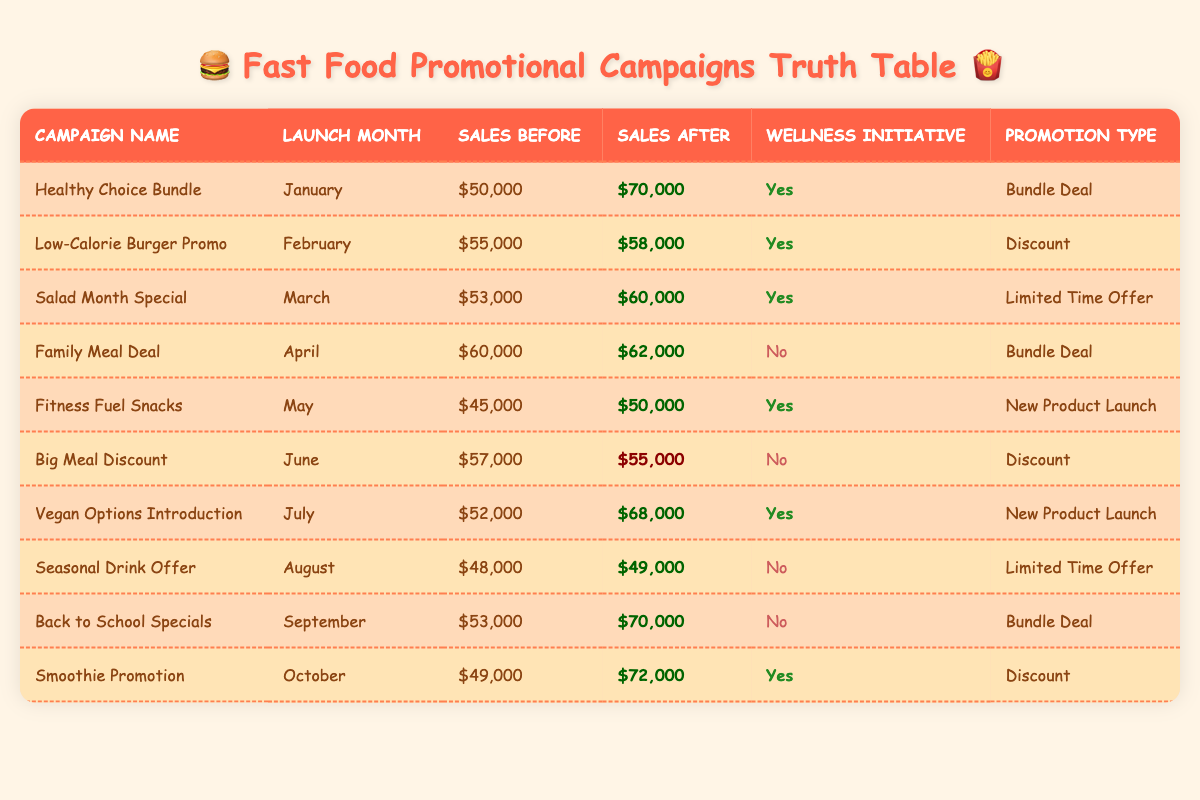What was the sales increase for the "Healthy Choice Bundle" campaign? The sales before the campaign were $50,000 and after the campaign, they rose to $70,000. The increase is calculated as $70,000 - $50,000 = $20,000.
Answer: $20,000 Which promotional campaign had the highest sales after its launch? Looking at the "Sales After" column, the highest value is $72,000 from the "Smoothie Promotion" campaign.
Answer: "Smoothie Promotion" Were there any campaigns that experienced a sales decrease? The table indicates a sales decrease for the "Big Meal Discount" campaign, where sales fell from $57,000 to $55,000.
Answer: Yes How many campaigns were part of a wellness initiative with sales increases? The campaigns "Healthy Choice Bundle", "Salad Month Special", "Fitness Fuel Snacks", "Vegan Options Introduction", and "Smoothie Promotion" all show sales increases. This totals to 5 campaigns.
Answer: 5 What was the average sales before campaigns launched during wellness initiatives? The sales before wellness initiatives are $50,000 (Healthy Choice Bundle), $55,000 (Low-Calorie Burger Promo), $53,000 (Salad Month Special), $45,000 (Fitness Fuel Snacks), $52,000 (Vegan Options Introduction), and $49,000 (Smoothie Promotion). The sum is $50,000 + $55,000 + $53,000 + $45,000 + $52,000 + $49,000 = $304,000. There are 6 campaigns, so the average is $304,000 / 6 = $50,666.67.
Answer: $50,666.67 Which month saw the lowest sales before a campaign, and what were those sales? The "Fitness Fuel Snacks" campaign launched in May with the lowest sales before the campaign at $45,000.
Answer: May, $45,000 